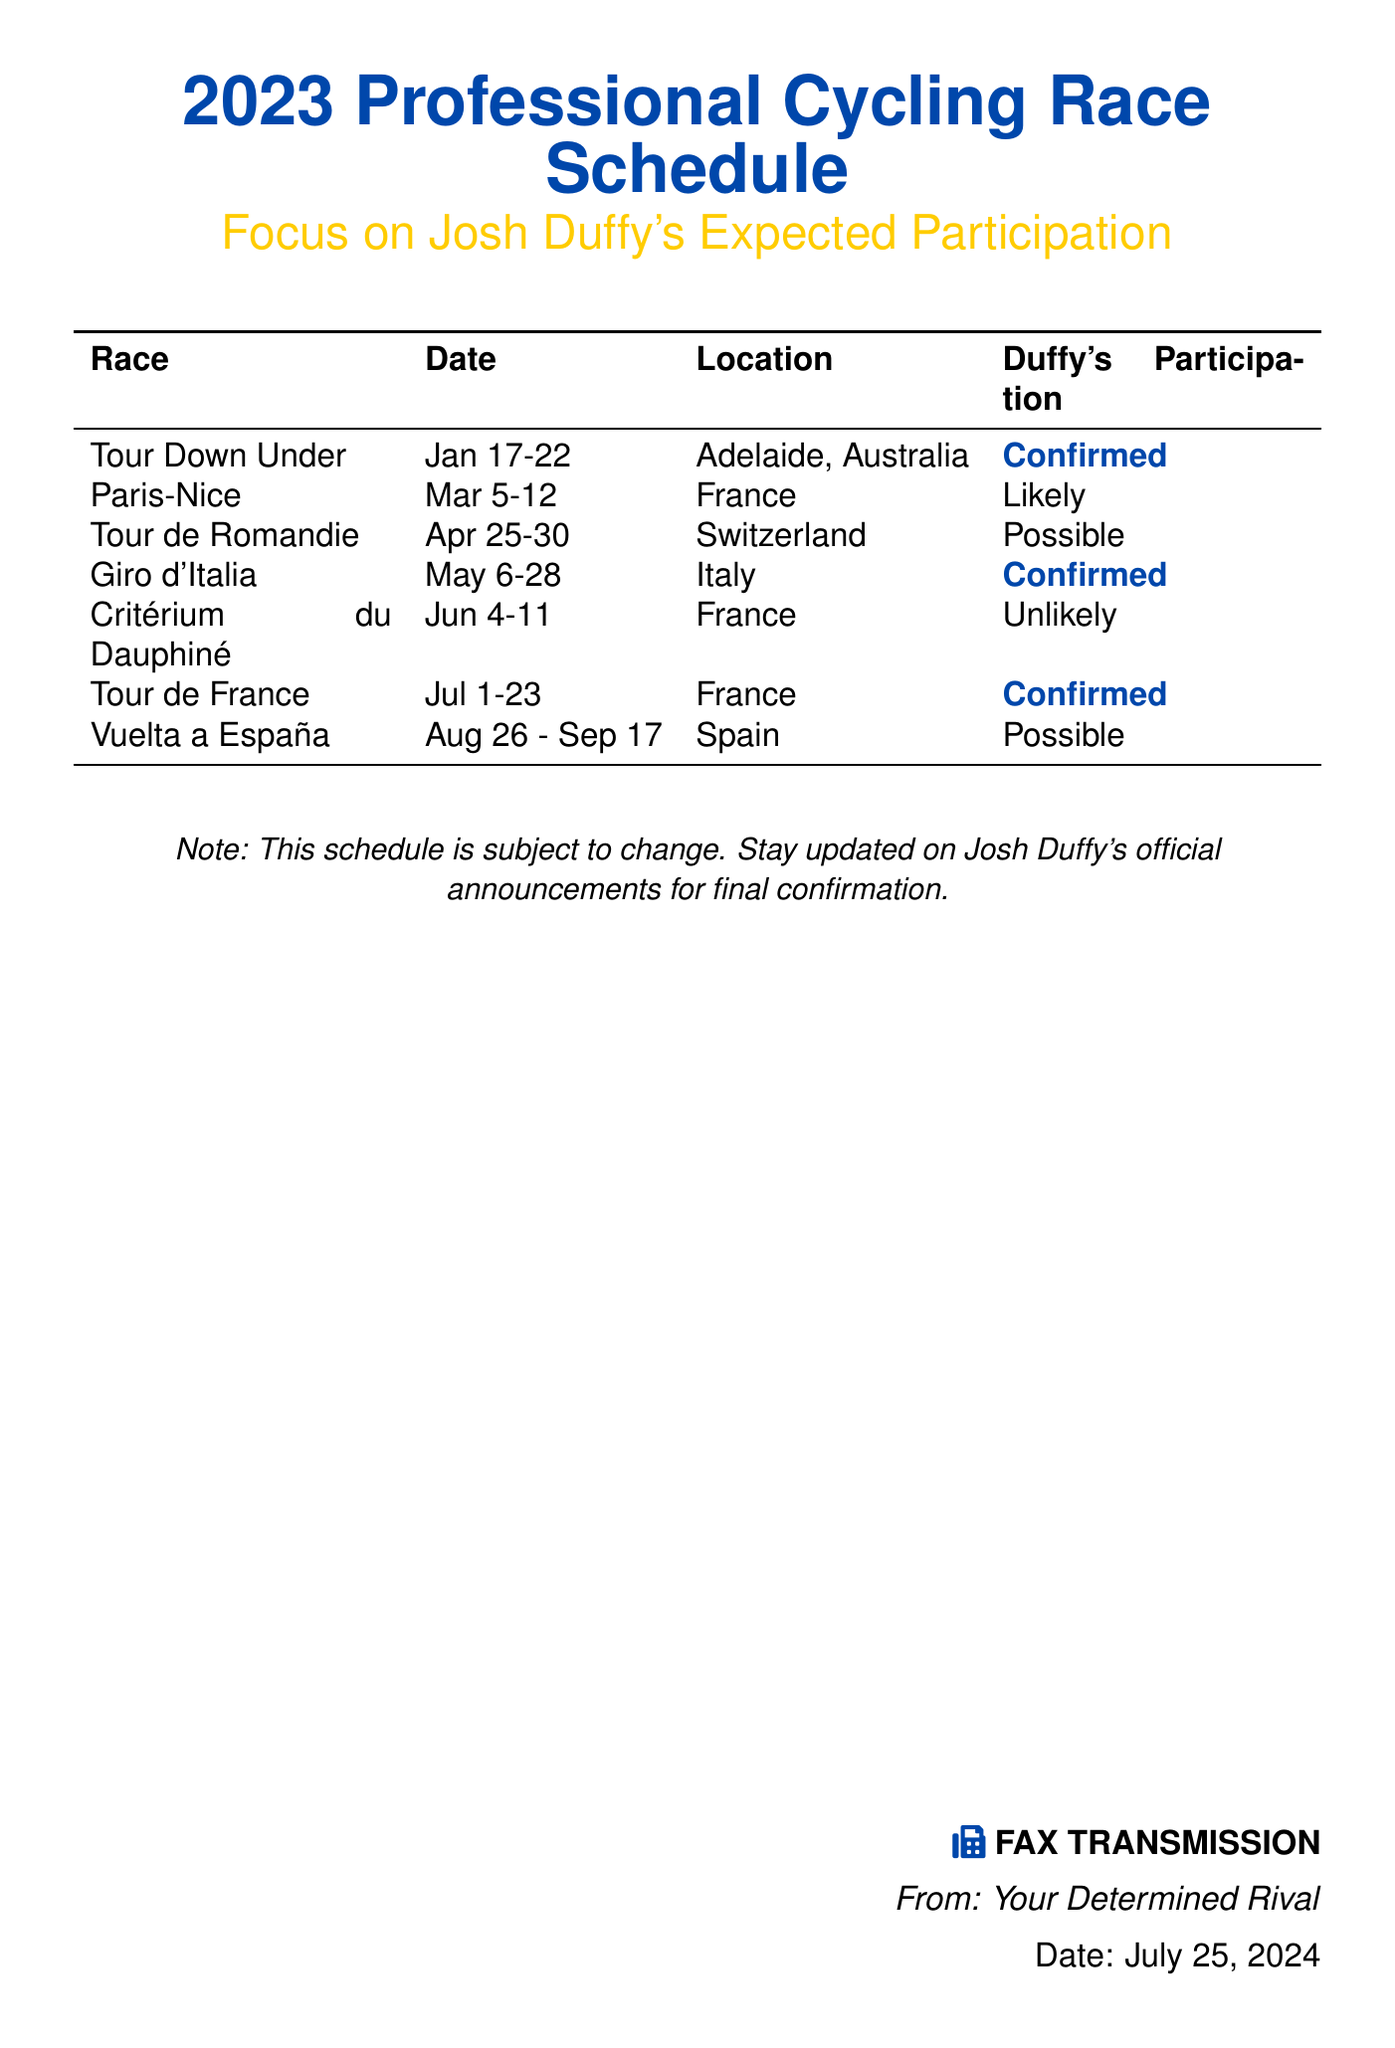what is the title of the fax? The title of the fax is prominently displayed and indicates the content regarding the cycling race schedule.
Answer: 2023 Professional Cycling Race Schedule who is the main focus of the schedule? The focus of the schedule highlights the participation of a specific cyclist.
Answer: Josh Duffy what is Duffy's participation status in the Tour Down Under? This event shows a clear status regarding Duffy's participation, highlighted in blue.
Answer: Confirmed which race is scheduled first in 2023? The races are listed in chronological order, starting from the earliest date.
Answer: Tour Down Under how many races does Duffy participate in with a confirmed status? The document specifically marks the total count of races with confirmed participation.
Answer: 3 when does the Giro d'Italia take place? The document provides specific dates for this key race in the cycling calendar.
Answer: May 6-28 in which country will the Critérium du Dauphiné happen? Each race has a designated location, which is crucial for understanding the cycling schedule.
Answer: France which race has a likely participation for Duffy? Participation likelihood varies by event, with some events less certain than others.
Answer: Paris-Nice how many total events are listed in the document? The total count of races shows the extent of the schedule for the season.
Answer: 7 what is the footer note about the schedule? The document includes a footer note that provides caution regarding potential changes.
Answer: This schedule is subject to change 